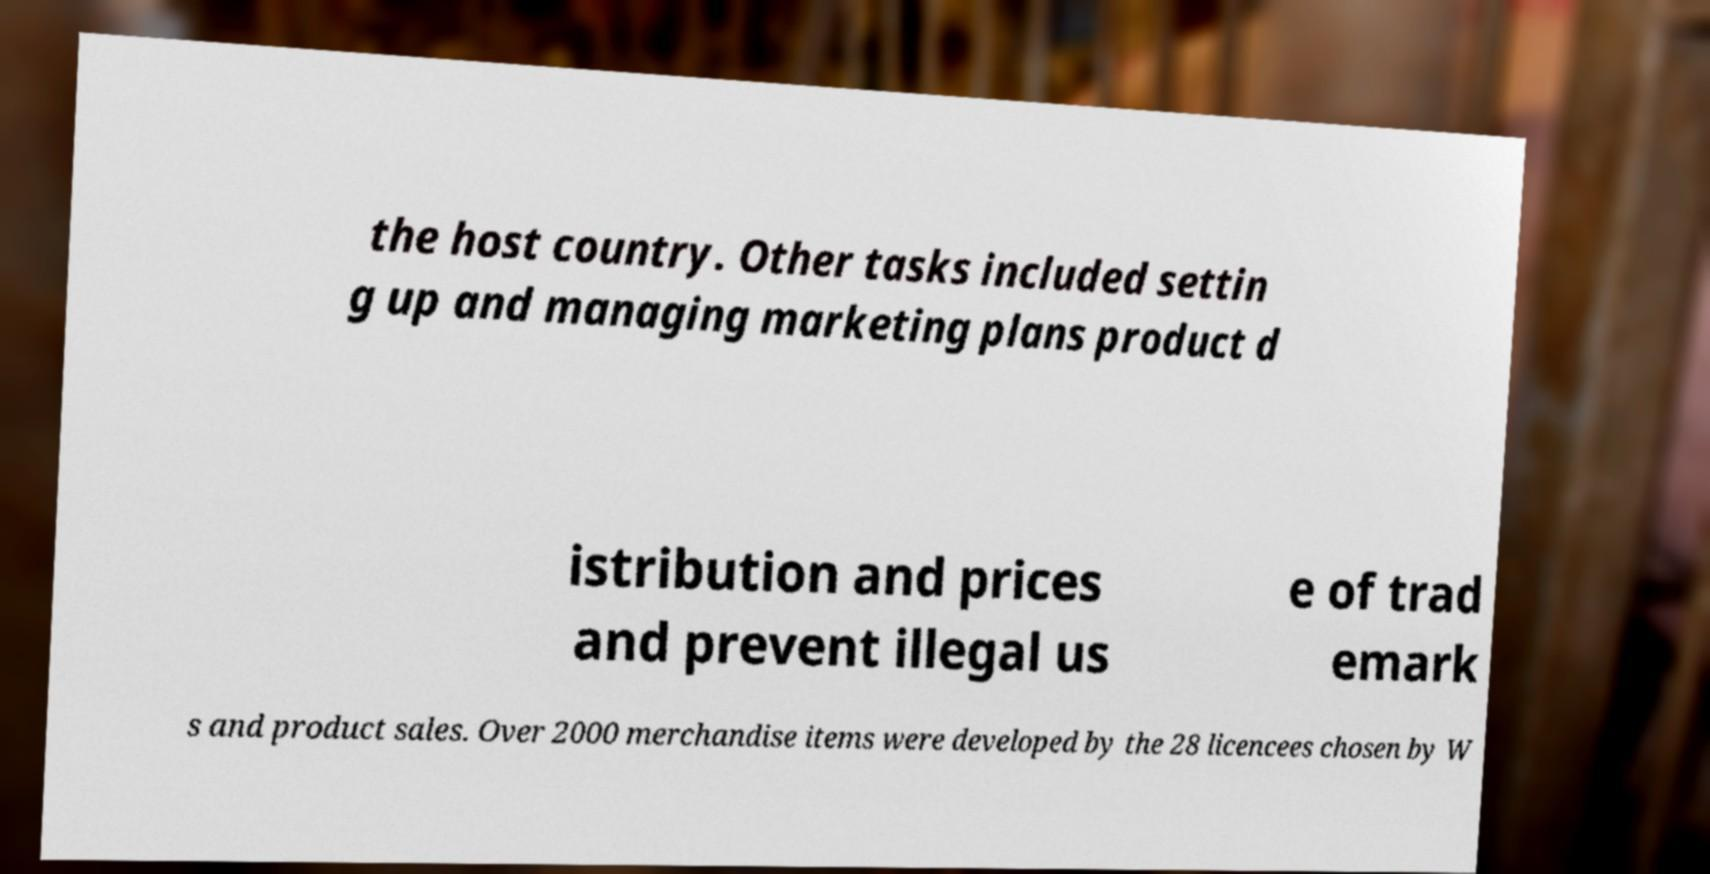For documentation purposes, I need the text within this image transcribed. Could you provide that? the host country. Other tasks included settin g up and managing marketing plans product d istribution and prices and prevent illegal us e of trad emark s and product sales. Over 2000 merchandise items were developed by the 28 licencees chosen by W 